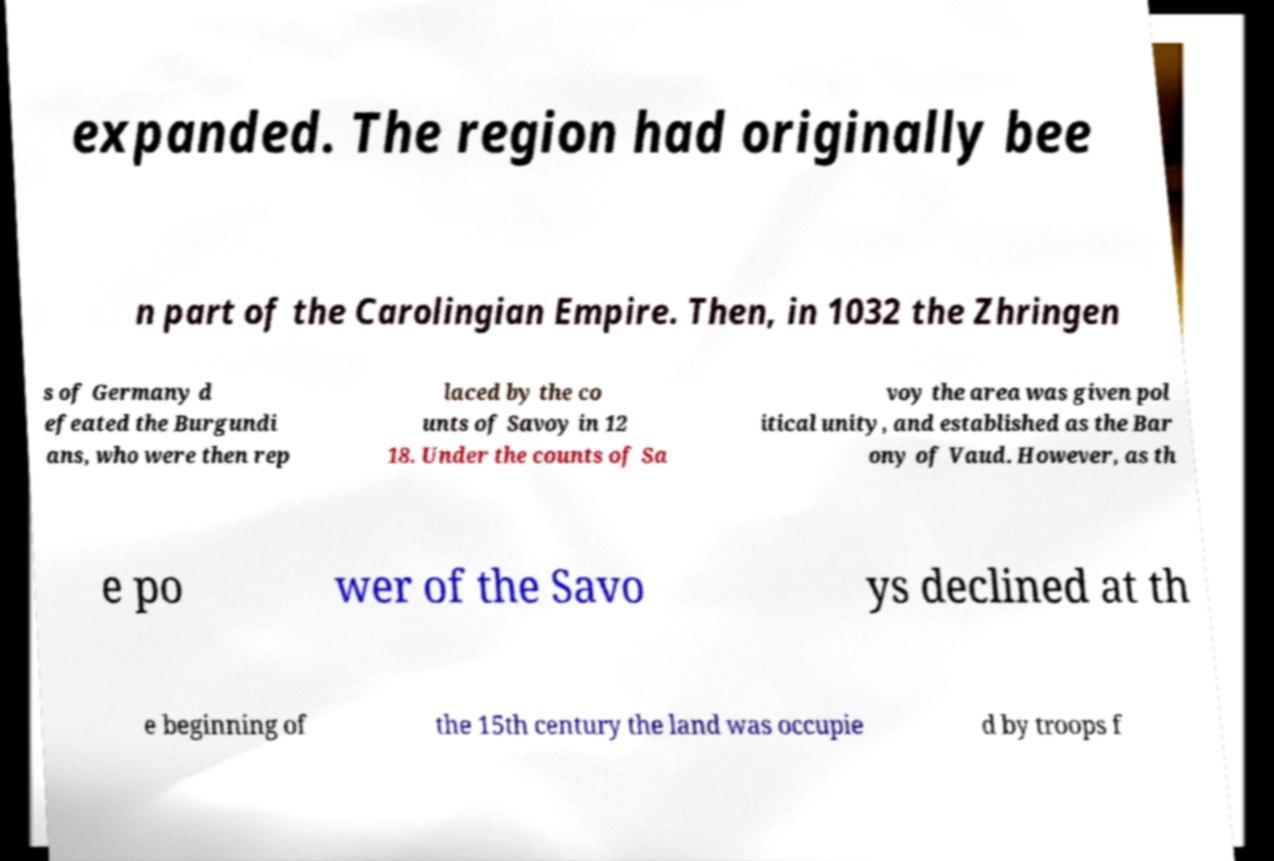For documentation purposes, I need the text within this image transcribed. Could you provide that? expanded. The region had originally bee n part of the Carolingian Empire. Then, in 1032 the Zhringen s of Germany d efeated the Burgundi ans, who were then rep laced by the co unts of Savoy in 12 18. Under the counts of Sa voy the area was given pol itical unity, and established as the Bar ony of Vaud. However, as th e po wer of the Savo ys declined at th e beginning of the 15th century the land was occupie d by troops f 